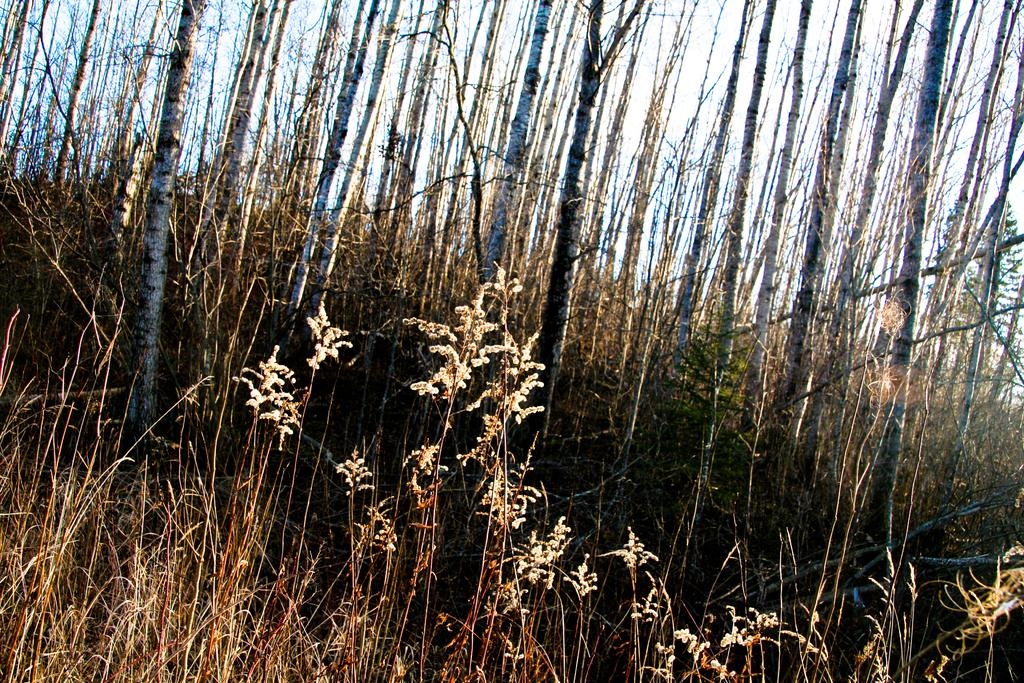What type of vegetation is present in the image? There are plants in the image. Can you identify any specific type of plant in the image? Yes, there are bamboo trees in the image. What is the price of the tiger in the image? There is no tiger present in the image, so it is not possible to determine its price. 